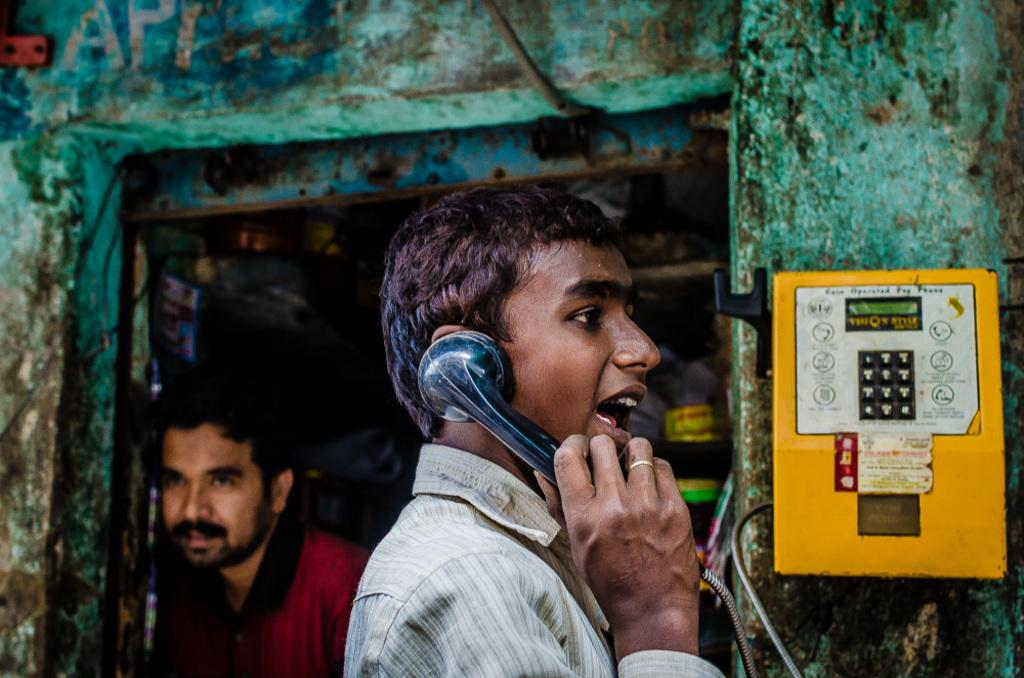What object can be seen on the right side of the image? There is a telephone on the right side of the image. How many people are present in the image? There are two people in the image. What is visible on the wall in the background of the image? There is text written on the wall in the background of the image. What is the name of the boat in the image? There is no boat present in the image. How comfortable are the chairs in the image? The provided facts do not mention any chairs or their comfort level. 